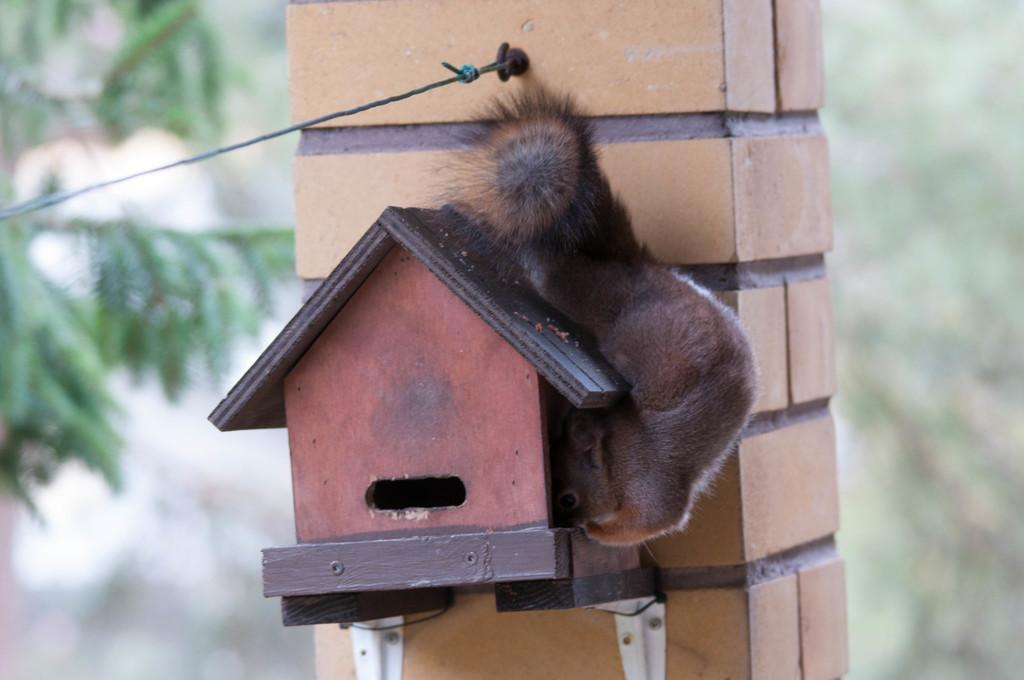What structure is located in the front of the image? There is a bird house in the front of the image. What else can be seen in the front of the image besides the bird house? There is an animal and a pillar in the front of the image. What is attached to the pillar in the front of the image? There is a rope attached to the pillar in the front of the image. What can be seen in the background of the image? The background of the image is blurry, but there are leaves visible. What type of soup is being served in the image? There is no soup present in the image. What type of hospital can be seen in the background of the image? There is no hospital present in the image; the background is blurry with leaves visible. 